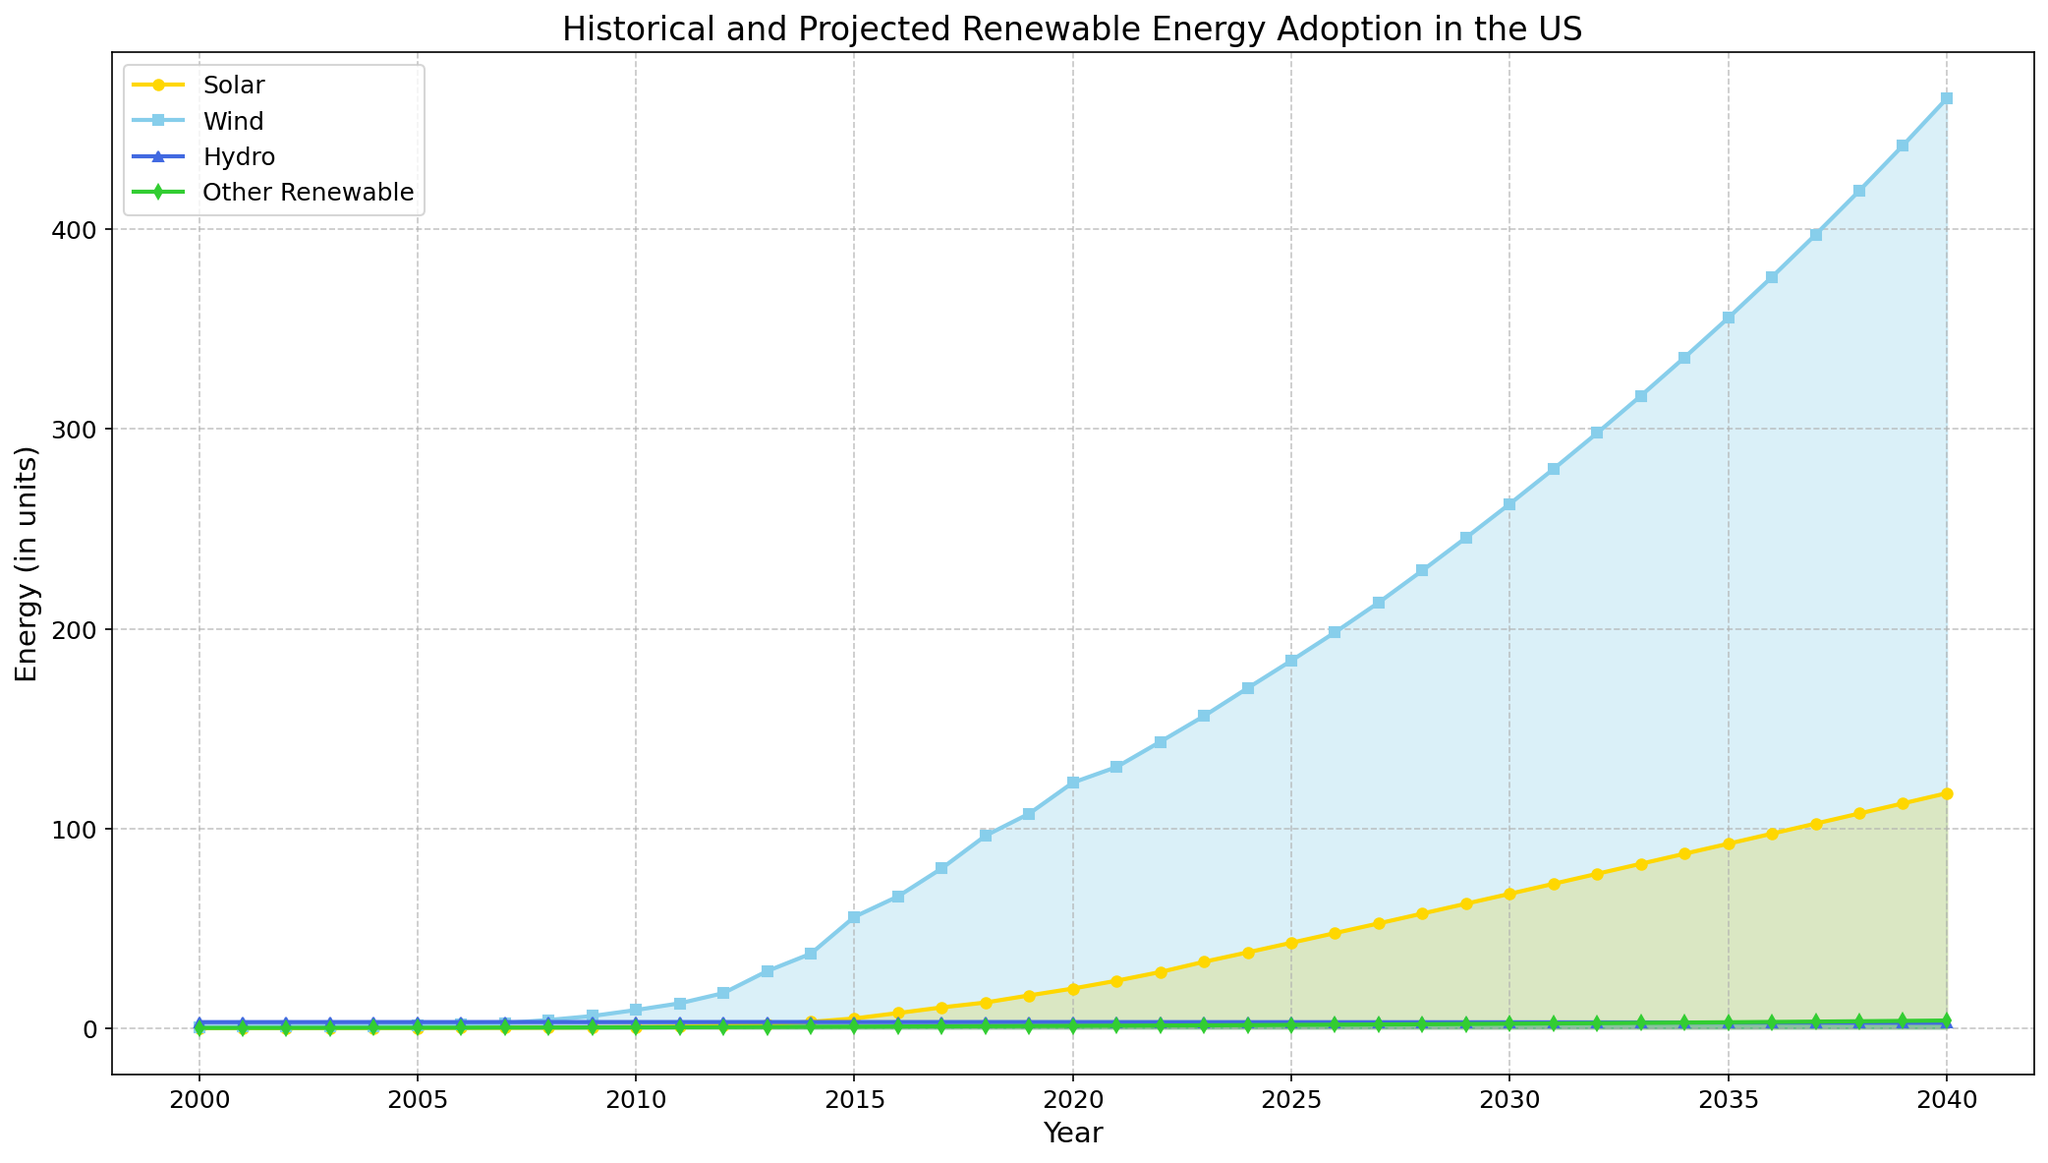What's the overall trend for solar energy adoption from 2000 to 2040? Looking at the golden line, it starts at a low value in 2000 and continually increases through the years up to 2040. This indicates a steady upward trend.
Answer: Steady upward trend How does wind energy adoption in 2020 compare to solar energy adoption in 2030? The skyblue line for wind energy in 2020 shows a value around 123, while the golden line for solar energy in 2030 is around 67. Therefore, wind energy in 2020 is significantly higher than solar energy in 2030.
Answer: Wind energy in 2020 is higher What interval of years shows the most significant increase for hydro energy? The royalblue line representing hydro energy remains relatively flat over the years, showing minimal change. This indicates there is no significant increase particularly.
Answer: No significant increase What's the difference between wind and solar energy adoption levels in 2035? In 2035, wind energy adoption (represented by the skyblue line) is approximately 356, and solar energy (golden line) is around 92. The difference can be calculated by 356 - 92.
Answer: 264 Which renewable energy source has the lowest value in the year 2040? Observing the end points for each line, the 'Other Renewable' category (green line) is the lowest, around 3.81 in 2040.
Answer: Other Renewable Between which two years does solar energy see the most rapid increase in adoption? Focusing on the golden line, the steepest slope occurs between 2015 and 2016, going from approximately 4.85 to 7.56.
Answer: 2015 to 2016 What is the projected adoption value of wind energy in 2030? The point on the skyblue line corresponding to the year 2030 is around 263.
Answer: Around 263 How does the adoption of 'Other Renewable' energies change from 2000 to 2040? Looking at the green line, it gradually increases from about 0.10 to 3.81, indicating a consistent upward trend over the years.
Answer: Consistent upward trend What is the average adoption value of solar energy between 2000 and 2010? Summing the values from 2000 to 2010: 0.06 + 0.08 + 0.09 + 0.10 + 0.12 + 0.14 + 0.18 + 0.22 + 0.28 + 0.39 + 0.55 gives 2.21. Dividing by the number of years (11) gives 2.21 / 11.
Answer: 0.20 Which renewable energy source outpaces the others the most in 2040? By 2040, the skyblue line representing wind energy reaches around 466, the highest among all the renewable sources.
Answer: Wind 